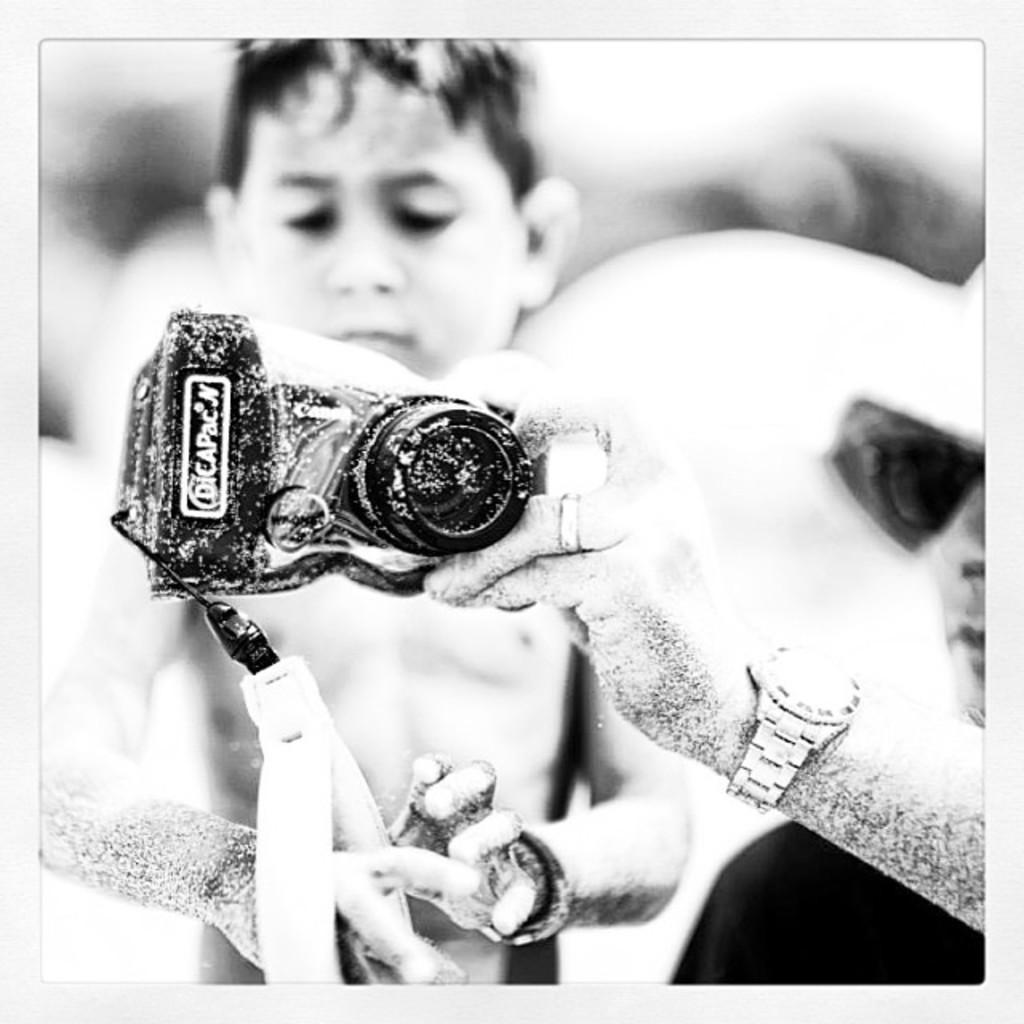Describe this image in one or two sentences. As we can see in the image there are two people. The man on the right side is wearing spectacles and holding a camera and the background is blurry. 